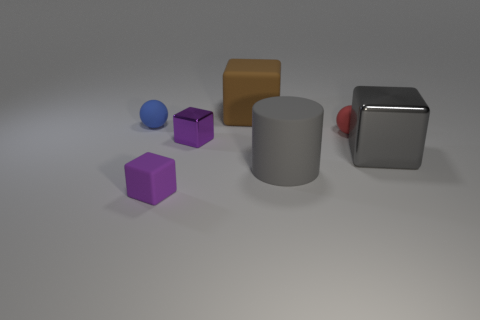Is there any other thing that is made of the same material as the tiny red ball?
Offer a terse response. Yes. The big brown matte object is what shape?
Your answer should be compact. Cube. There is a blue object that is the same size as the purple metal thing; what is its shape?
Your answer should be compact. Sphere. Is there anything else that is the same color as the matte cylinder?
Ensure brevity in your answer.  Yes. What size is the blue sphere that is the same material as the tiny red object?
Offer a very short reply. Small. Do the small purple shiny thing and the brown thing that is behind the big gray matte cylinder have the same shape?
Your answer should be very brief. Yes. What size is the gray rubber thing?
Offer a terse response. Large. Are there fewer balls in front of the gray rubber object than big yellow blocks?
Keep it short and to the point. No. How many purple cubes have the same size as the blue matte sphere?
Keep it short and to the point. 2. There is a metal object that is the same color as the matte cylinder; what is its shape?
Your answer should be compact. Cube. 